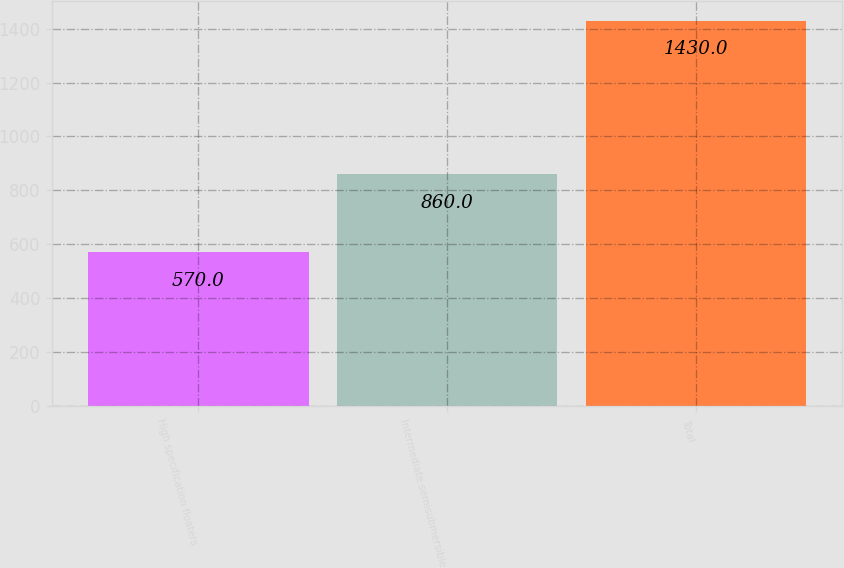<chart> <loc_0><loc_0><loc_500><loc_500><bar_chart><fcel>High specification floaters<fcel>Intermediate semisubmersible<fcel>Total<nl><fcel>570<fcel>860<fcel>1430<nl></chart> 